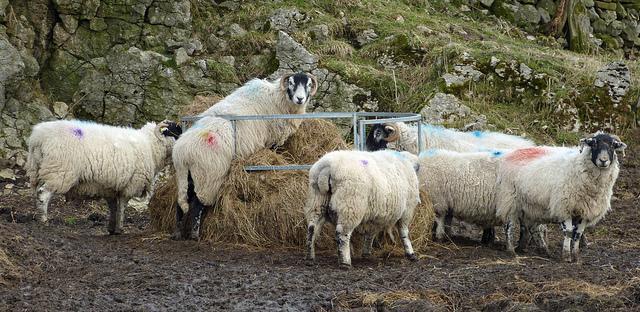How many sheep can you see?
Give a very brief answer. 6. 